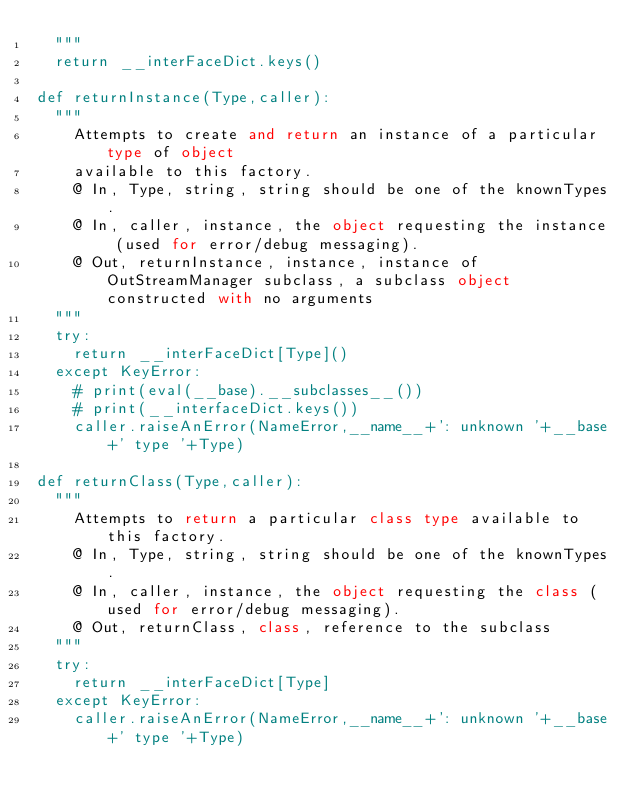Convert code to text. <code><loc_0><loc_0><loc_500><loc_500><_Python_>  """
  return __interFaceDict.keys()

def returnInstance(Type,caller):
  """
    Attempts to create and return an instance of a particular type of object
    available to this factory.
    @ In, Type, string, string should be one of the knownTypes.
    @ In, caller, instance, the object requesting the instance (used for error/debug messaging).
    @ Out, returnInstance, instance, instance of OutStreamManager subclass, a subclass object constructed with no arguments
  """
  try:
    return __interFaceDict[Type]()
  except KeyError:
    # print(eval(__base).__subclasses__())
    # print(__interfaceDict.keys())
    caller.raiseAnError(NameError,__name__+': unknown '+__base+' type '+Type)

def returnClass(Type,caller):
  """
    Attempts to return a particular class type available to this factory.
    @ In, Type, string, string should be one of the knownTypes.
    @ In, caller, instance, the object requesting the class (used for error/debug messaging).
    @ Out, returnClass, class, reference to the subclass
  """
  try:
    return __interFaceDict[Type]
  except KeyError:
    caller.raiseAnError(NameError,__name__+': unknown '+__base+' type '+Type)
</code> 